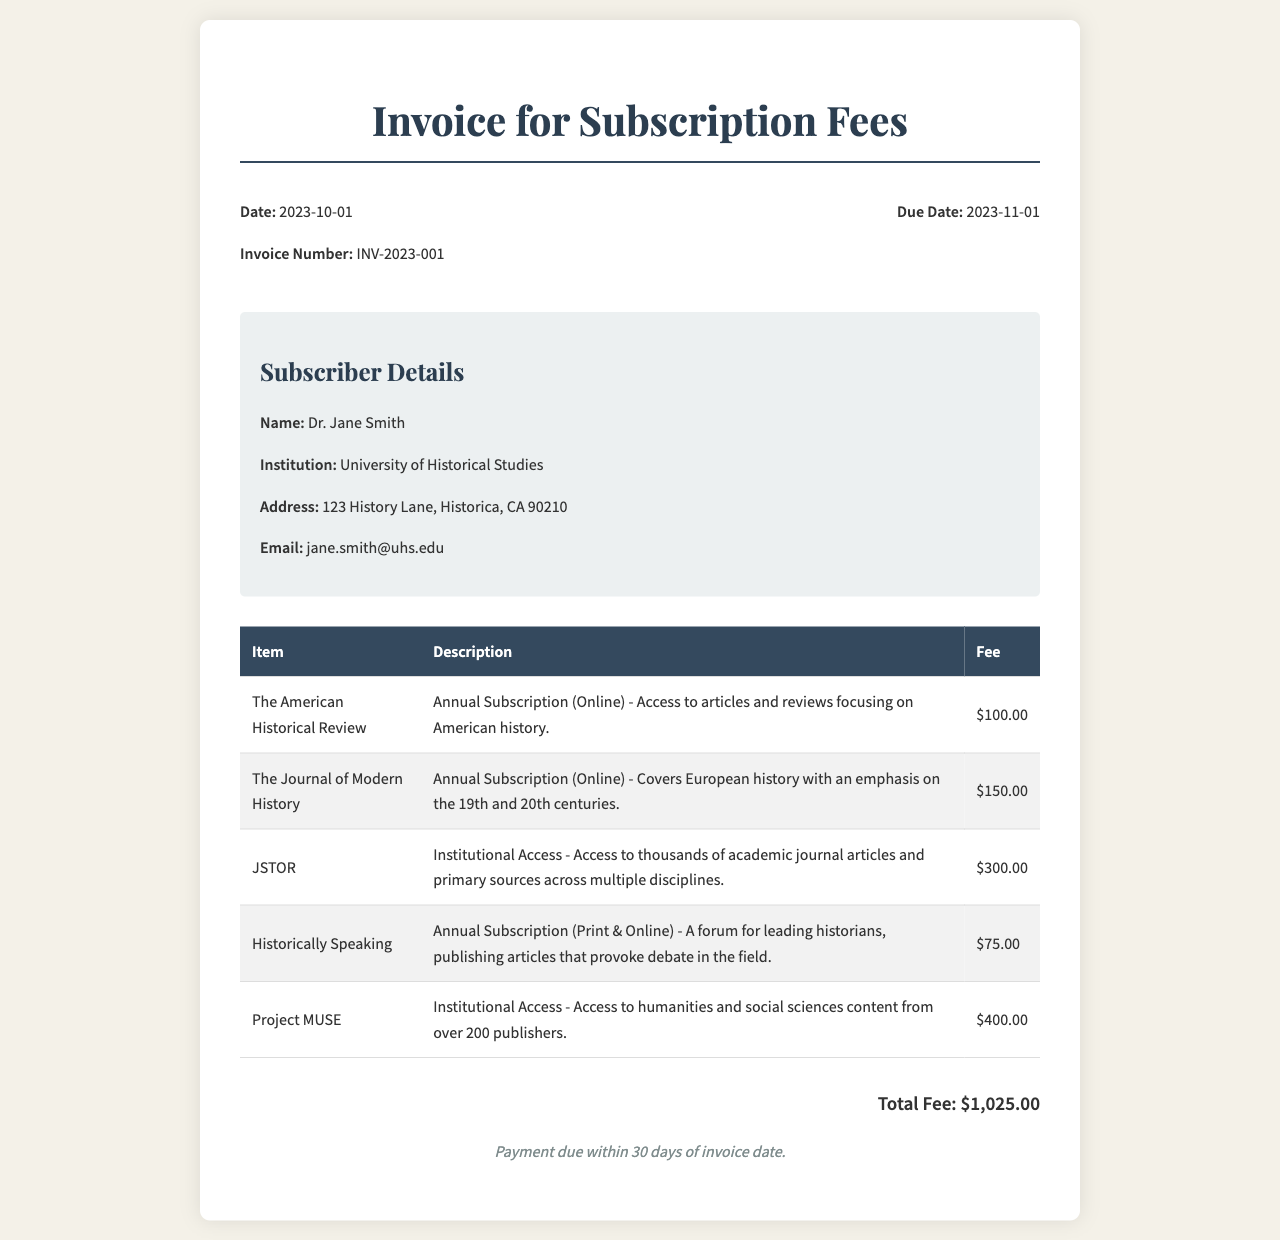What is the date of the invoice? The date of the invoice is stated in the header details of the document.
Answer: 2023-10-01 Who is the subscriber? The subscriber's name is provided in the subscriber details section of the invoice.
Answer: Dr. Jane Smith What is the total fee? The total fee is summarized at the end of the invoice, representing the sum of all individual subscriptions and fees.
Answer: $1,025.00 How many journal subscriptions are listed? The number of subscriptions can be counted from the rows in the subscription table.
Answer: 5 What type of access does JSTOR provide? The type of access for JSTOR is mentioned in its description within the invoice.
Answer: Institutional Access What is the due date for payment? The due date is specified in the header details section of the document.
Answer: 2023-11-01 What is the fee for "Historically Speaking"? This fee is found in the subscription table under the respective item.
Answer: $75.00 Which subscription covers European history? This can be determined by examining the descriptions of the subscriptions listed.
Answer: The Journal of Modern History What should the payment terms be adhered to? The payment terms are provided at the bottom of the invoice.
Answer: Payment due within 30 days of invoice date 